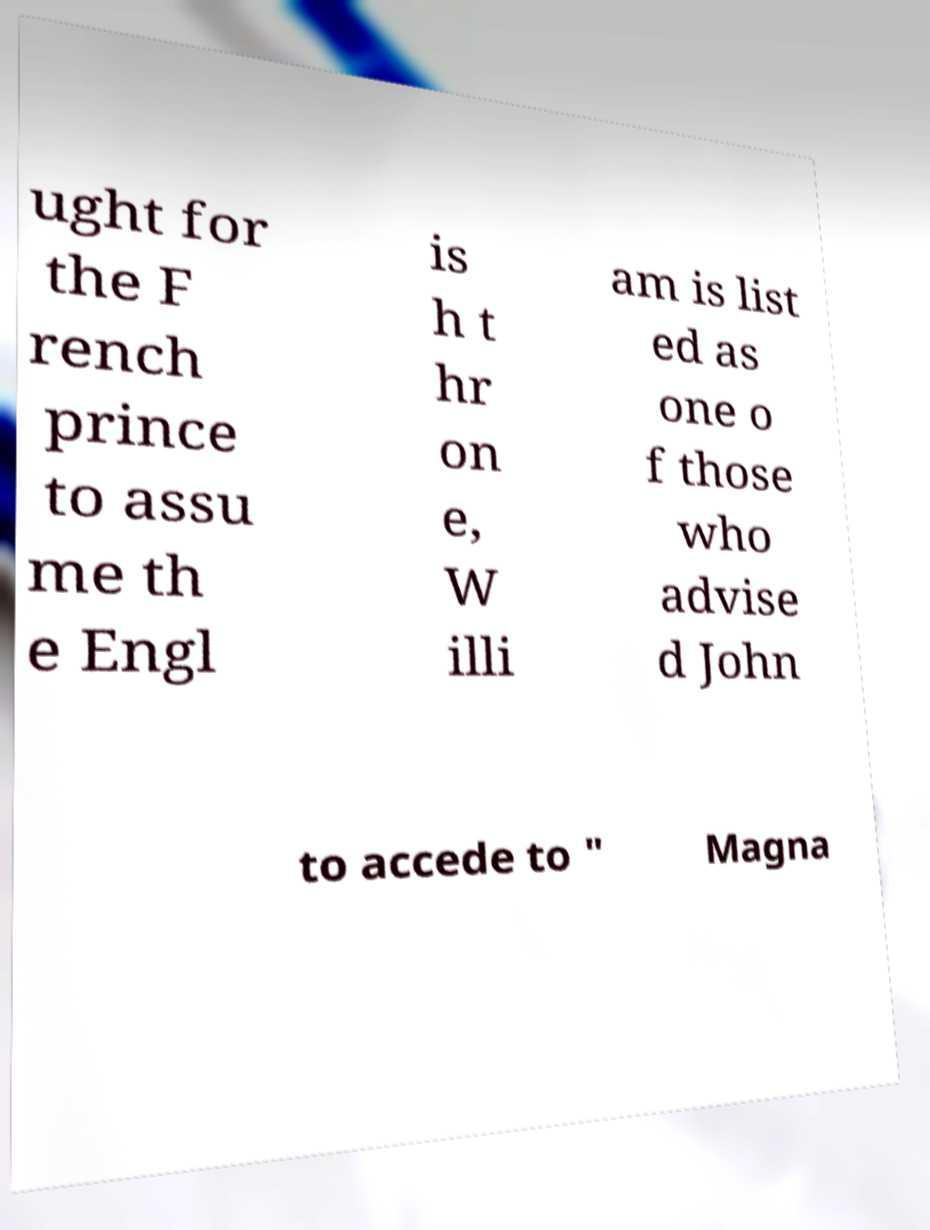Please identify and transcribe the text found in this image. ught for the F rench prince to assu me th e Engl is h t hr on e, W illi am is list ed as one o f those who advise d John to accede to " Magna 